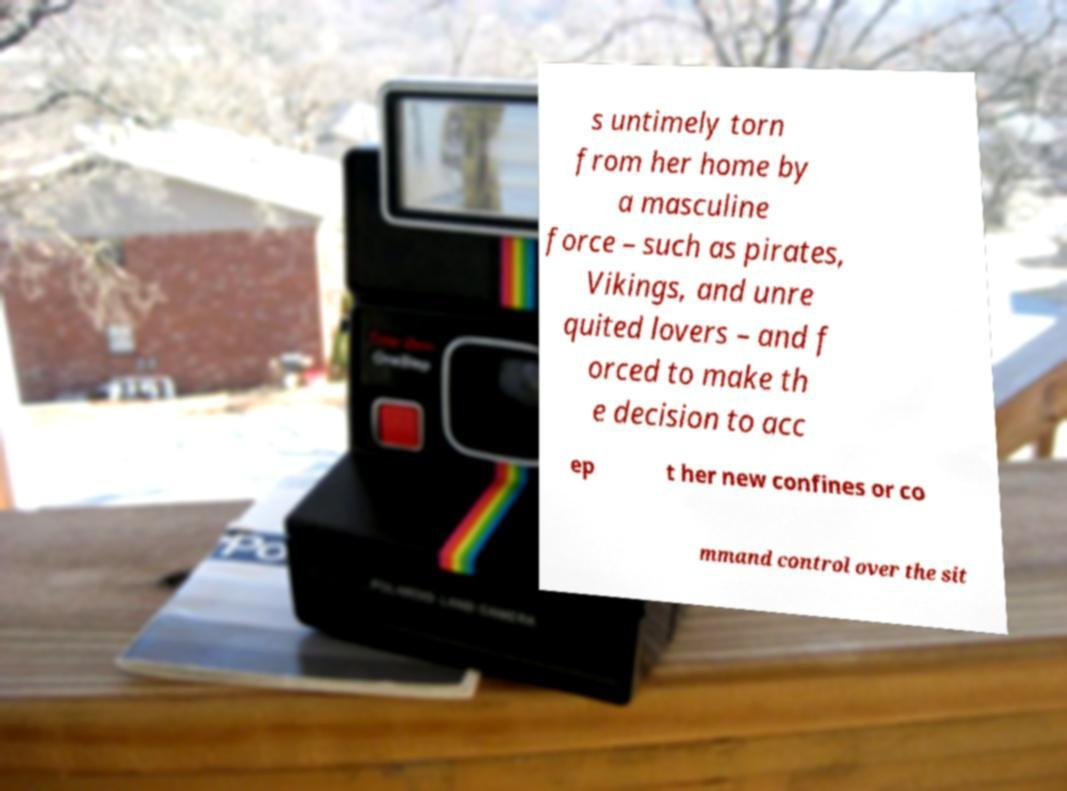Can you accurately transcribe the text from the provided image for me? s untimely torn from her home by a masculine force – such as pirates, Vikings, and unre quited lovers – and f orced to make th e decision to acc ep t her new confines or co mmand control over the sit 